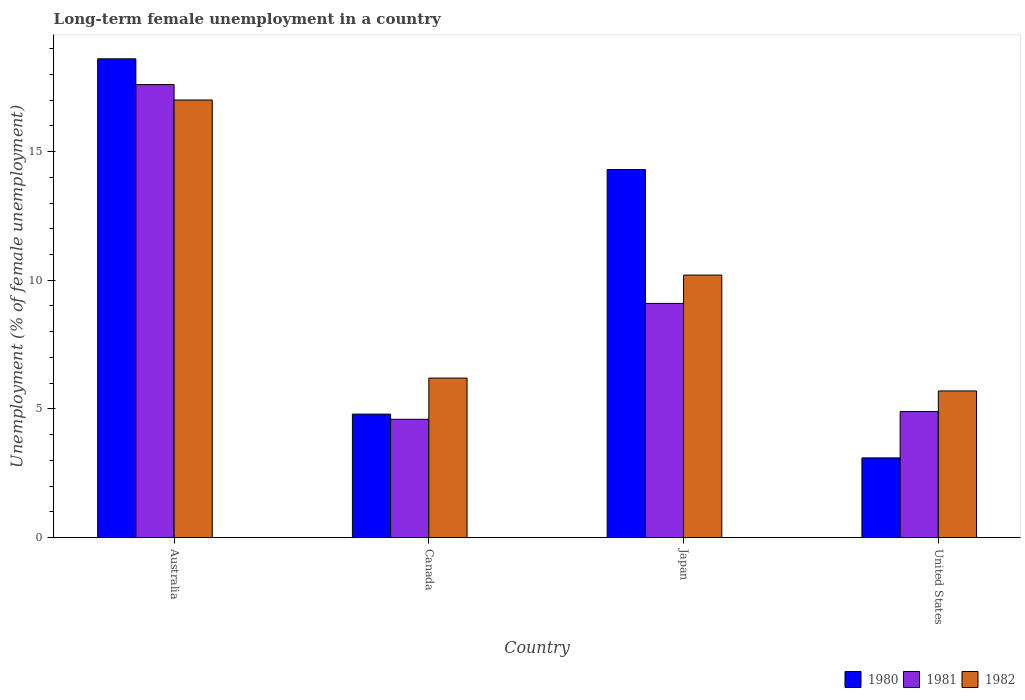How many groups of bars are there?
Your answer should be compact. 4. Are the number of bars per tick equal to the number of legend labels?
Your response must be concise. Yes. How many bars are there on the 3rd tick from the left?
Offer a very short reply. 3. How many bars are there on the 1st tick from the right?
Your response must be concise. 3. In how many cases, is the number of bars for a given country not equal to the number of legend labels?
Ensure brevity in your answer.  0. What is the percentage of long-term unemployed female population in 1982 in United States?
Ensure brevity in your answer.  5.7. Across all countries, what is the maximum percentage of long-term unemployed female population in 1980?
Provide a succinct answer. 18.6. Across all countries, what is the minimum percentage of long-term unemployed female population in 1982?
Provide a succinct answer. 5.7. In which country was the percentage of long-term unemployed female population in 1980 minimum?
Offer a terse response. United States. What is the total percentage of long-term unemployed female population in 1981 in the graph?
Keep it short and to the point. 36.2. What is the difference between the percentage of long-term unemployed female population in 1982 in Australia and that in United States?
Make the answer very short. 11.3. What is the difference between the percentage of long-term unemployed female population in 1982 in Australia and the percentage of long-term unemployed female population in 1981 in Japan?
Your answer should be compact. 7.9. What is the average percentage of long-term unemployed female population in 1982 per country?
Offer a terse response. 9.77. What is the difference between the percentage of long-term unemployed female population of/in 1980 and percentage of long-term unemployed female population of/in 1982 in Canada?
Keep it short and to the point. -1.4. What is the ratio of the percentage of long-term unemployed female population in 1982 in Canada to that in Japan?
Offer a terse response. 0.61. Is the difference between the percentage of long-term unemployed female population in 1980 in Japan and United States greater than the difference between the percentage of long-term unemployed female population in 1982 in Japan and United States?
Your answer should be compact. Yes. What is the difference between the highest and the second highest percentage of long-term unemployed female population in 1982?
Ensure brevity in your answer.  6.8. What is the difference between the highest and the lowest percentage of long-term unemployed female population in 1980?
Offer a very short reply. 15.5. In how many countries, is the percentage of long-term unemployed female population in 1982 greater than the average percentage of long-term unemployed female population in 1982 taken over all countries?
Keep it short and to the point. 2. Is the sum of the percentage of long-term unemployed female population in 1982 in Canada and Japan greater than the maximum percentage of long-term unemployed female population in 1980 across all countries?
Offer a very short reply. No. What does the 2nd bar from the right in Canada represents?
Offer a terse response. 1981. Is it the case that in every country, the sum of the percentage of long-term unemployed female population in 1981 and percentage of long-term unemployed female population in 1980 is greater than the percentage of long-term unemployed female population in 1982?
Make the answer very short. Yes. How many bars are there?
Ensure brevity in your answer.  12. Are all the bars in the graph horizontal?
Keep it short and to the point. No. How many countries are there in the graph?
Your answer should be very brief. 4. Are the values on the major ticks of Y-axis written in scientific E-notation?
Your response must be concise. No. Does the graph contain any zero values?
Provide a short and direct response. No. Does the graph contain grids?
Keep it short and to the point. No. Where does the legend appear in the graph?
Your response must be concise. Bottom right. How are the legend labels stacked?
Offer a terse response. Horizontal. What is the title of the graph?
Your response must be concise. Long-term female unemployment in a country. Does "1977" appear as one of the legend labels in the graph?
Your answer should be compact. No. What is the label or title of the Y-axis?
Ensure brevity in your answer.  Unemployment (% of female unemployment). What is the Unemployment (% of female unemployment) in 1980 in Australia?
Provide a short and direct response. 18.6. What is the Unemployment (% of female unemployment) in 1981 in Australia?
Provide a short and direct response. 17.6. What is the Unemployment (% of female unemployment) of 1980 in Canada?
Your response must be concise. 4.8. What is the Unemployment (% of female unemployment) of 1981 in Canada?
Give a very brief answer. 4.6. What is the Unemployment (% of female unemployment) of 1982 in Canada?
Offer a very short reply. 6.2. What is the Unemployment (% of female unemployment) of 1980 in Japan?
Your response must be concise. 14.3. What is the Unemployment (% of female unemployment) of 1981 in Japan?
Make the answer very short. 9.1. What is the Unemployment (% of female unemployment) in 1982 in Japan?
Give a very brief answer. 10.2. What is the Unemployment (% of female unemployment) in 1980 in United States?
Your answer should be compact. 3.1. What is the Unemployment (% of female unemployment) of 1981 in United States?
Offer a very short reply. 4.9. What is the Unemployment (% of female unemployment) of 1982 in United States?
Give a very brief answer. 5.7. Across all countries, what is the maximum Unemployment (% of female unemployment) in 1980?
Provide a short and direct response. 18.6. Across all countries, what is the maximum Unemployment (% of female unemployment) in 1981?
Offer a very short reply. 17.6. Across all countries, what is the maximum Unemployment (% of female unemployment) of 1982?
Make the answer very short. 17. Across all countries, what is the minimum Unemployment (% of female unemployment) in 1980?
Give a very brief answer. 3.1. Across all countries, what is the minimum Unemployment (% of female unemployment) of 1981?
Ensure brevity in your answer.  4.6. Across all countries, what is the minimum Unemployment (% of female unemployment) of 1982?
Give a very brief answer. 5.7. What is the total Unemployment (% of female unemployment) of 1980 in the graph?
Make the answer very short. 40.8. What is the total Unemployment (% of female unemployment) in 1981 in the graph?
Ensure brevity in your answer.  36.2. What is the total Unemployment (% of female unemployment) in 1982 in the graph?
Offer a terse response. 39.1. What is the difference between the Unemployment (% of female unemployment) in 1980 in Australia and that in Canada?
Give a very brief answer. 13.8. What is the difference between the Unemployment (% of female unemployment) of 1981 in Australia and that in United States?
Offer a very short reply. 12.7. What is the difference between the Unemployment (% of female unemployment) in 1982 in Australia and that in United States?
Offer a very short reply. 11.3. What is the difference between the Unemployment (% of female unemployment) of 1981 in Canada and that in Japan?
Ensure brevity in your answer.  -4.5. What is the difference between the Unemployment (% of female unemployment) of 1980 in Japan and that in United States?
Provide a short and direct response. 11.2. What is the difference between the Unemployment (% of female unemployment) in 1981 in Japan and that in United States?
Offer a terse response. 4.2. What is the difference between the Unemployment (% of female unemployment) of 1980 in Australia and the Unemployment (% of female unemployment) of 1981 in Canada?
Make the answer very short. 14. What is the difference between the Unemployment (% of female unemployment) of 1980 in Australia and the Unemployment (% of female unemployment) of 1981 in United States?
Your answer should be compact. 13.7. What is the difference between the Unemployment (% of female unemployment) in 1981 in Canada and the Unemployment (% of female unemployment) in 1982 in Japan?
Your answer should be very brief. -5.6. What is the difference between the Unemployment (% of female unemployment) of 1980 in Japan and the Unemployment (% of female unemployment) of 1981 in United States?
Give a very brief answer. 9.4. What is the difference between the Unemployment (% of female unemployment) of 1981 in Japan and the Unemployment (% of female unemployment) of 1982 in United States?
Your answer should be compact. 3.4. What is the average Unemployment (% of female unemployment) of 1980 per country?
Offer a very short reply. 10.2. What is the average Unemployment (% of female unemployment) of 1981 per country?
Your answer should be very brief. 9.05. What is the average Unemployment (% of female unemployment) in 1982 per country?
Provide a succinct answer. 9.78. What is the difference between the Unemployment (% of female unemployment) in 1980 and Unemployment (% of female unemployment) in 1982 in Australia?
Make the answer very short. 1.6. What is the difference between the Unemployment (% of female unemployment) in 1981 and Unemployment (% of female unemployment) in 1982 in Australia?
Make the answer very short. 0.6. What is the difference between the Unemployment (% of female unemployment) of 1980 and Unemployment (% of female unemployment) of 1982 in Canada?
Keep it short and to the point. -1.4. What is the difference between the Unemployment (% of female unemployment) in 1981 and Unemployment (% of female unemployment) in 1982 in Canada?
Keep it short and to the point. -1.6. What is the difference between the Unemployment (% of female unemployment) of 1981 and Unemployment (% of female unemployment) of 1982 in United States?
Give a very brief answer. -0.8. What is the ratio of the Unemployment (% of female unemployment) in 1980 in Australia to that in Canada?
Offer a very short reply. 3.88. What is the ratio of the Unemployment (% of female unemployment) in 1981 in Australia to that in Canada?
Keep it short and to the point. 3.83. What is the ratio of the Unemployment (% of female unemployment) of 1982 in Australia to that in Canada?
Your answer should be compact. 2.74. What is the ratio of the Unemployment (% of female unemployment) in 1980 in Australia to that in Japan?
Ensure brevity in your answer.  1.3. What is the ratio of the Unemployment (% of female unemployment) of 1981 in Australia to that in Japan?
Provide a succinct answer. 1.93. What is the ratio of the Unemployment (% of female unemployment) in 1980 in Australia to that in United States?
Provide a short and direct response. 6. What is the ratio of the Unemployment (% of female unemployment) of 1981 in Australia to that in United States?
Provide a succinct answer. 3.59. What is the ratio of the Unemployment (% of female unemployment) of 1982 in Australia to that in United States?
Keep it short and to the point. 2.98. What is the ratio of the Unemployment (% of female unemployment) of 1980 in Canada to that in Japan?
Offer a terse response. 0.34. What is the ratio of the Unemployment (% of female unemployment) of 1981 in Canada to that in Japan?
Keep it short and to the point. 0.51. What is the ratio of the Unemployment (% of female unemployment) in 1982 in Canada to that in Japan?
Offer a terse response. 0.61. What is the ratio of the Unemployment (% of female unemployment) in 1980 in Canada to that in United States?
Keep it short and to the point. 1.55. What is the ratio of the Unemployment (% of female unemployment) of 1981 in Canada to that in United States?
Your answer should be compact. 0.94. What is the ratio of the Unemployment (% of female unemployment) in 1982 in Canada to that in United States?
Your response must be concise. 1.09. What is the ratio of the Unemployment (% of female unemployment) of 1980 in Japan to that in United States?
Keep it short and to the point. 4.61. What is the ratio of the Unemployment (% of female unemployment) of 1981 in Japan to that in United States?
Your answer should be very brief. 1.86. What is the ratio of the Unemployment (% of female unemployment) in 1982 in Japan to that in United States?
Provide a short and direct response. 1.79. What is the difference between the highest and the second highest Unemployment (% of female unemployment) in 1980?
Offer a terse response. 4.3. What is the difference between the highest and the second highest Unemployment (% of female unemployment) in 1981?
Your answer should be compact. 8.5. What is the difference between the highest and the lowest Unemployment (% of female unemployment) of 1980?
Make the answer very short. 15.5. What is the difference between the highest and the lowest Unemployment (% of female unemployment) in 1981?
Offer a terse response. 13. What is the difference between the highest and the lowest Unemployment (% of female unemployment) in 1982?
Give a very brief answer. 11.3. 